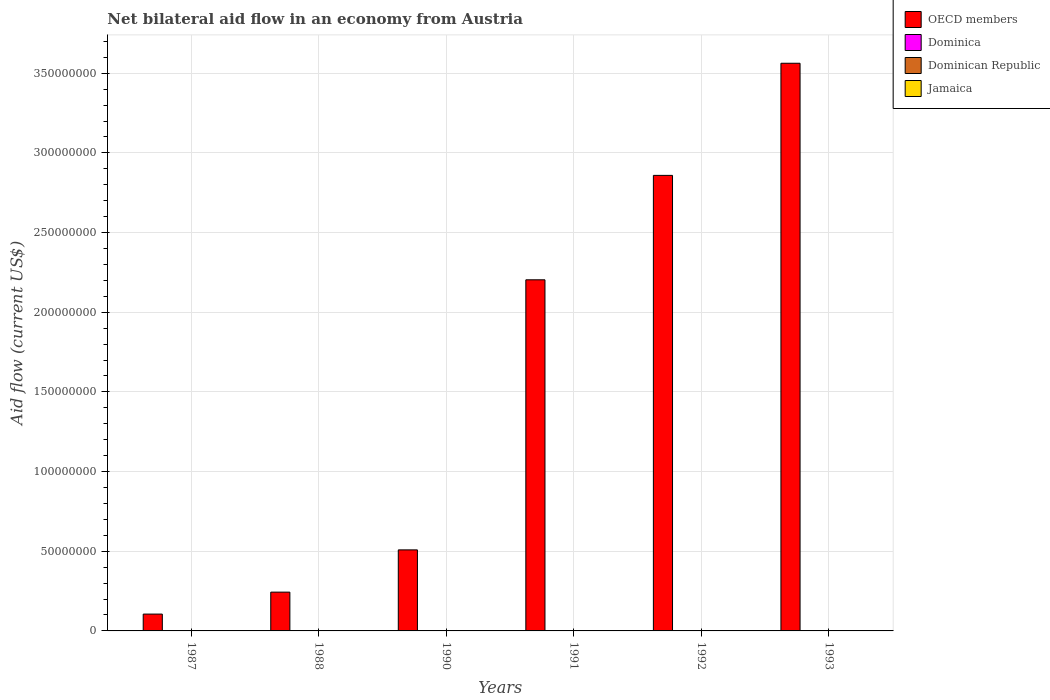How many different coloured bars are there?
Ensure brevity in your answer.  4. How many groups of bars are there?
Give a very brief answer. 6. Are the number of bars per tick equal to the number of legend labels?
Provide a succinct answer. Yes. How many bars are there on the 2nd tick from the left?
Keep it short and to the point. 4. How many bars are there on the 4th tick from the right?
Give a very brief answer. 4. In how many cases, is the number of bars for a given year not equal to the number of legend labels?
Your answer should be very brief. 0. What is the net bilateral aid flow in Dominica in 1990?
Keep it short and to the point. 10000. Across all years, what is the maximum net bilateral aid flow in Dominica?
Make the answer very short. 10000. Across all years, what is the minimum net bilateral aid flow in OECD members?
Give a very brief answer. 1.06e+07. In which year was the net bilateral aid flow in Jamaica maximum?
Give a very brief answer. 1990. In which year was the net bilateral aid flow in OECD members minimum?
Offer a terse response. 1987. What is the total net bilateral aid flow in Jamaica in the graph?
Make the answer very short. 1.20e+05. What is the difference between the net bilateral aid flow in OECD members in 1987 and that in 1988?
Your response must be concise. -1.38e+07. What is the average net bilateral aid flow in OECD members per year?
Offer a very short reply. 1.58e+08. In the year 1993, what is the difference between the net bilateral aid flow in OECD members and net bilateral aid flow in Dominican Republic?
Make the answer very short. 3.56e+08. What is the ratio of the net bilateral aid flow in OECD members in 1987 to that in 1988?
Your response must be concise. 0.43. Is the difference between the net bilateral aid flow in OECD members in 1988 and 1991 greater than the difference between the net bilateral aid flow in Dominican Republic in 1988 and 1991?
Your answer should be compact. No. What is the difference between the highest and the lowest net bilateral aid flow in Dominican Republic?
Ensure brevity in your answer.  3.00e+04. In how many years, is the net bilateral aid flow in Dominica greater than the average net bilateral aid flow in Dominica taken over all years?
Provide a succinct answer. 0. Is the sum of the net bilateral aid flow in Dominica in 1990 and 1991 greater than the maximum net bilateral aid flow in Jamaica across all years?
Keep it short and to the point. No. Is it the case that in every year, the sum of the net bilateral aid flow in Jamaica and net bilateral aid flow in OECD members is greater than the sum of net bilateral aid flow in Dominican Republic and net bilateral aid flow in Dominica?
Your answer should be very brief. Yes. What does the 1st bar from the left in 1990 represents?
Ensure brevity in your answer.  OECD members. What does the 1st bar from the right in 1993 represents?
Your answer should be compact. Jamaica. Is it the case that in every year, the sum of the net bilateral aid flow in Dominican Republic and net bilateral aid flow in OECD members is greater than the net bilateral aid flow in Dominica?
Your response must be concise. Yes. How many bars are there?
Make the answer very short. 24. Are all the bars in the graph horizontal?
Your answer should be compact. No. Does the graph contain any zero values?
Provide a short and direct response. No. Does the graph contain grids?
Your response must be concise. Yes. Where does the legend appear in the graph?
Make the answer very short. Top right. How are the legend labels stacked?
Give a very brief answer. Vertical. What is the title of the graph?
Give a very brief answer. Net bilateral aid flow in an economy from Austria. Does "Saudi Arabia" appear as one of the legend labels in the graph?
Your response must be concise. No. What is the label or title of the Y-axis?
Make the answer very short. Aid flow (current US$). What is the Aid flow (current US$) of OECD members in 1987?
Ensure brevity in your answer.  1.06e+07. What is the Aid flow (current US$) of Dominica in 1987?
Offer a terse response. 10000. What is the Aid flow (current US$) of Dominican Republic in 1987?
Make the answer very short. 2.00e+04. What is the Aid flow (current US$) in Jamaica in 1987?
Offer a terse response. 10000. What is the Aid flow (current US$) of OECD members in 1988?
Offer a terse response. 2.43e+07. What is the Aid flow (current US$) of Dominica in 1988?
Offer a terse response. 10000. What is the Aid flow (current US$) of Dominican Republic in 1988?
Your response must be concise. 10000. What is the Aid flow (current US$) in OECD members in 1990?
Make the answer very short. 5.09e+07. What is the Aid flow (current US$) of Dominican Republic in 1990?
Make the answer very short. 2.00e+04. What is the Aid flow (current US$) in OECD members in 1991?
Offer a terse response. 2.20e+08. What is the Aid flow (current US$) of Dominican Republic in 1991?
Your answer should be compact. 3.00e+04. What is the Aid flow (current US$) in OECD members in 1992?
Provide a short and direct response. 2.86e+08. What is the Aid flow (current US$) in Dominica in 1992?
Your answer should be very brief. 10000. What is the Aid flow (current US$) of Jamaica in 1992?
Offer a terse response. 3.00e+04. What is the Aid flow (current US$) of OECD members in 1993?
Keep it short and to the point. 3.56e+08. What is the Aid flow (current US$) of Dominica in 1993?
Give a very brief answer. 10000. What is the Aid flow (current US$) in Dominican Republic in 1993?
Provide a succinct answer. 4.00e+04. What is the Aid flow (current US$) of Jamaica in 1993?
Offer a terse response. 2.00e+04. Across all years, what is the maximum Aid flow (current US$) in OECD members?
Your answer should be very brief. 3.56e+08. Across all years, what is the maximum Aid flow (current US$) of Dominica?
Your response must be concise. 10000. Across all years, what is the minimum Aid flow (current US$) of OECD members?
Offer a terse response. 1.06e+07. Across all years, what is the minimum Aid flow (current US$) of Dominica?
Ensure brevity in your answer.  10000. Across all years, what is the minimum Aid flow (current US$) in Dominican Republic?
Make the answer very short. 10000. What is the total Aid flow (current US$) in OECD members in the graph?
Your response must be concise. 9.48e+08. What is the total Aid flow (current US$) of Dominica in the graph?
Offer a terse response. 6.00e+04. What is the total Aid flow (current US$) of Dominican Republic in the graph?
Provide a short and direct response. 1.60e+05. What is the total Aid flow (current US$) in Jamaica in the graph?
Ensure brevity in your answer.  1.20e+05. What is the difference between the Aid flow (current US$) in OECD members in 1987 and that in 1988?
Offer a terse response. -1.38e+07. What is the difference between the Aid flow (current US$) of Dominica in 1987 and that in 1988?
Make the answer very short. 0. What is the difference between the Aid flow (current US$) of Dominican Republic in 1987 and that in 1988?
Give a very brief answer. 10000. What is the difference between the Aid flow (current US$) of Jamaica in 1987 and that in 1988?
Your answer should be compact. 0. What is the difference between the Aid flow (current US$) of OECD members in 1987 and that in 1990?
Make the answer very short. -4.03e+07. What is the difference between the Aid flow (current US$) of OECD members in 1987 and that in 1991?
Give a very brief answer. -2.10e+08. What is the difference between the Aid flow (current US$) of Dominica in 1987 and that in 1991?
Your answer should be very brief. 0. What is the difference between the Aid flow (current US$) in Jamaica in 1987 and that in 1991?
Provide a short and direct response. 0. What is the difference between the Aid flow (current US$) of OECD members in 1987 and that in 1992?
Your answer should be very brief. -2.75e+08. What is the difference between the Aid flow (current US$) in Dominica in 1987 and that in 1992?
Your answer should be compact. 0. What is the difference between the Aid flow (current US$) in Dominican Republic in 1987 and that in 1992?
Your answer should be very brief. -2.00e+04. What is the difference between the Aid flow (current US$) in OECD members in 1987 and that in 1993?
Offer a very short reply. -3.46e+08. What is the difference between the Aid flow (current US$) of Dominica in 1987 and that in 1993?
Offer a very short reply. 0. What is the difference between the Aid flow (current US$) of OECD members in 1988 and that in 1990?
Provide a succinct answer. -2.65e+07. What is the difference between the Aid flow (current US$) in Dominican Republic in 1988 and that in 1990?
Your answer should be compact. -10000. What is the difference between the Aid flow (current US$) of OECD members in 1988 and that in 1991?
Offer a terse response. -1.96e+08. What is the difference between the Aid flow (current US$) in Dominican Republic in 1988 and that in 1991?
Provide a short and direct response. -2.00e+04. What is the difference between the Aid flow (current US$) in Jamaica in 1988 and that in 1991?
Ensure brevity in your answer.  0. What is the difference between the Aid flow (current US$) of OECD members in 1988 and that in 1992?
Keep it short and to the point. -2.62e+08. What is the difference between the Aid flow (current US$) in Dominica in 1988 and that in 1992?
Offer a very short reply. 0. What is the difference between the Aid flow (current US$) of Dominican Republic in 1988 and that in 1992?
Ensure brevity in your answer.  -3.00e+04. What is the difference between the Aid flow (current US$) in Jamaica in 1988 and that in 1992?
Ensure brevity in your answer.  -2.00e+04. What is the difference between the Aid flow (current US$) of OECD members in 1988 and that in 1993?
Provide a succinct answer. -3.32e+08. What is the difference between the Aid flow (current US$) of Jamaica in 1988 and that in 1993?
Make the answer very short. -10000. What is the difference between the Aid flow (current US$) in OECD members in 1990 and that in 1991?
Ensure brevity in your answer.  -1.70e+08. What is the difference between the Aid flow (current US$) of Dominica in 1990 and that in 1991?
Make the answer very short. 0. What is the difference between the Aid flow (current US$) of Dominican Republic in 1990 and that in 1991?
Keep it short and to the point. -10000. What is the difference between the Aid flow (current US$) of OECD members in 1990 and that in 1992?
Your answer should be compact. -2.35e+08. What is the difference between the Aid flow (current US$) of Dominica in 1990 and that in 1992?
Your response must be concise. 0. What is the difference between the Aid flow (current US$) of Jamaica in 1990 and that in 1992?
Offer a terse response. 10000. What is the difference between the Aid flow (current US$) in OECD members in 1990 and that in 1993?
Provide a short and direct response. -3.05e+08. What is the difference between the Aid flow (current US$) in Dominica in 1990 and that in 1993?
Provide a short and direct response. 0. What is the difference between the Aid flow (current US$) in Dominican Republic in 1990 and that in 1993?
Make the answer very short. -2.00e+04. What is the difference between the Aid flow (current US$) in Jamaica in 1990 and that in 1993?
Keep it short and to the point. 2.00e+04. What is the difference between the Aid flow (current US$) of OECD members in 1991 and that in 1992?
Keep it short and to the point. -6.55e+07. What is the difference between the Aid flow (current US$) in Dominica in 1991 and that in 1992?
Keep it short and to the point. 0. What is the difference between the Aid flow (current US$) of Dominican Republic in 1991 and that in 1992?
Your response must be concise. -10000. What is the difference between the Aid flow (current US$) of Jamaica in 1991 and that in 1992?
Keep it short and to the point. -2.00e+04. What is the difference between the Aid flow (current US$) of OECD members in 1991 and that in 1993?
Give a very brief answer. -1.36e+08. What is the difference between the Aid flow (current US$) of Dominican Republic in 1991 and that in 1993?
Your answer should be very brief. -10000. What is the difference between the Aid flow (current US$) in Jamaica in 1991 and that in 1993?
Your answer should be compact. -10000. What is the difference between the Aid flow (current US$) in OECD members in 1992 and that in 1993?
Your response must be concise. -7.04e+07. What is the difference between the Aid flow (current US$) of Dominican Republic in 1992 and that in 1993?
Your response must be concise. 0. What is the difference between the Aid flow (current US$) in OECD members in 1987 and the Aid flow (current US$) in Dominica in 1988?
Provide a short and direct response. 1.06e+07. What is the difference between the Aid flow (current US$) of OECD members in 1987 and the Aid flow (current US$) of Dominican Republic in 1988?
Provide a succinct answer. 1.06e+07. What is the difference between the Aid flow (current US$) in OECD members in 1987 and the Aid flow (current US$) in Jamaica in 1988?
Your answer should be very brief. 1.06e+07. What is the difference between the Aid flow (current US$) of Dominica in 1987 and the Aid flow (current US$) of Dominican Republic in 1988?
Provide a short and direct response. 0. What is the difference between the Aid flow (current US$) of Dominica in 1987 and the Aid flow (current US$) of Jamaica in 1988?
Provide a succinct answer. 0. What is the difference between the Aid flow (current US$) in OECD members in 1987 and the Aid flow (current US$) in Dominica in 1990?
Make the answer very short. 1.06e+07. What is the difference between the Aid flow (current US$) of OECD members in 1987 and the Aid flow (current US$) of Dominican Republic in 1990?
Provide a short and direct response. 1.06e+07. What is the difference between the Aid flow (current US$) of OECD members in 1987 and the Aid flow (current US$) of Jamaica in 1990?
Give a very brief answer. 1.05e+07. What is the difference between the Aid flow (current US$) in Dominica in 1987 and the Aid flow (current US$) in Dominican Republic in 1990?
Keep it short and to the point. -10000. What is the difference between the Aid flow (current US$) in OECD members in 1987 and the Aid flow (current US$) in Dominica in 1991?
Make the answer very short. 1.06e+07. What is the difference between the Aid flow (current US$) in OECD members in 1987 and the Aid flow (current US$) in Dominican Republic in 1991?
Give a very brief answer. 1.05e+07. What is the difference between the Aid flow (current US$) in OECD members in 1987 and the Aid flow (current US$) in Jamaica in 1991?
Make the answer very short. 1.06e+07. What is the difference between the Aid flow (current US$) of Dominica in 1987 and the Aid flow (current US$) of Dominican Republic in 1991?
Give a very brief answer. -2.00e+04. What is the difference between the Aid flow (current US$) in OECD members in 1987 and the Aid flow (current US$) in Dominica in 1992?
Keep it short and to the point. 1.06e+07. What is the difference between the Aid flow (current US$) in OECD members in 1987 and the Aid flow (current US$) in Dominican Republic in 1992?
Provide a short and direct response. 1.05e+07. What is the difference between the Aid flow (current US$) of OECD members in 1987 and the Aid flow (current US$) of Jamaica in 1992?
Ensure brevity in your answer.  1.05e+07. What is the difference between the Aid flow (current US$) in Dominica in 1987 and the Aid flow (current US$) in Jamaica in 1992?
Provide a short and direct response. -2.00e+04. What is the difference between the Aid flow (current US$) in Dominican Republic in 1987 and the Aid flow (current US$) in Jamaica in 1992?
Your answer should be compact. -10000. What is the difference between the Aid flow (current US$) in OECD members in 1987 and the Aid flow (current US$) in Dominica in 1993?
Keep it short and to the point. 1.06e+07. What is the difference between the Aid flow (current US$) in OECD members in 1987 and the Aid flow (current US$) in Dominican Republic in 1993?
Keep it short and to the point. 1.05e+07. What is the difference between the Aid flow (current US$) of OECD members in 1987 and the Aid flow (current US$) of Jamaica in 1993?
Give a very brief answer. 1.06e+07. What is the difference between the Aid flow (current US$) in Dominican Republic in 1987 and the Aid flow (current US$) in Jamaica in 1993?
Your response must be concise. 0. What is the difference between the Aid flow (current US$) in OECD members in 1988 and the Aid flow (current US$) in Dominica in 1990?
Provide a succinct answer. 2.43e+07. What is the difference between the Aid flow (current US$) of OECD members in 1988 and the Aid flow (current US$) of Dominican Republic in 1990?
Offer a terse response. 2.43e+07. What is the difference between the Aid flow (current US$) of OECD members in 1988 and the Aid flow (current US$) of Jamaica in 1990?
Keep it short and to the point. 2.43e+07. What is the difference between the Aid flow (current US$) of Dominica in 1988 and the Aid flow (current US$) of Dominican Republic in 1990?
Provide a succinct answer. -10000. What is the difference between the Aid flow (current US$) in Dominican Republic in 1988 and the Aid flow (current US$) in Jamaica in 1990?
Your response must be concise. -3.00e+04. What is the difference between the Aid flow (current US$) of OECD members in 1988 and the Aid flow (current US$) of Dominica in 1991?
Keep it short and to the point. 2.43e+07. What is the difference between the Aid flow (current US$) of OECD members in 1988 and the Aid flow (current US$) of Dominican Republic in 1991?
Give a very brief answer. 2.43e+07. What is the difference between the Aid flow (current US$) in OECD members in 1988 and the Aid flow (current US$) in Jamaica in 1991?
Offer a terse response. 2.43e+07. What is the difference between the Aid flow (current US$) in Dominica in 1988 and the Aid flow (current US$) in Dominican Republic in 1991?
Your answer should be compact. -2.00e+04. What is the difference between the Aid flow (current US$) in Dominica in 1988 and the Aid flow (current US$) in Jamaica in 1991?
Offer a very short reply. 0. What is the difference between the Aid flow (current US$) of Dominican Republic in 1988 and the Aid flow (current US$) of Jamaica in 1991?
Provide a short and direct response. 0. What is the difference between the Aid flow (current US$) in OECD members in 1988 and the Aid flow (current US$) in Dominica in 1992?
Offer a terse response. 2.43e+07. What is the difference between the Aid flow (current US$) in OECD members in 1988 and the Aid flow (current US$) in Dominican Republic in 1992?
Make the answer very short. 2.43e+07. What is the difference between the Aid flow (current US$) of OECD members in 1988 and the Aid flow (current US$) of Jamaica in 1992?
Your response must be concise. 2.43e+07. What is the difference between the Aid flow (current US$) of Dominica in 1988 and the Aid flow (current US$) of Dominican Republic in 1992?
Give a very brief answer. -3.00e+04. What is the difference between the Aid flow (current US$) of Dominica in 1988 and the Aid flow (current US$) of Jamaica in 1992?
Give a very brief answer. -2.00e+04. What is the difference between the Aid flow (current US$) in OECD members in 1988 and the Aid flow (current US$) in Dominica in 1993?
Offer a very short reply. 2.43e+07. What is the difference between the Aid flow (current US$) of OECD members in 1988 and the Aid flow (current US$) of Dominican Republic in 1993?
Give a very brief answer. 2.43e+07. What is the difference between the Aid flow (current US$) in OECD members in 1988 and the Aid flow (current US$) in Jamaica in 1993?
Ensure brevity in your answer.  2.43e+07. What is the difference between the Aid flow (current US$) of Dominican Republic in 1988 and the Aid flow (current US$) of Jamaica in 1993?
Offer a terse response. -10000. What is the difference between the Aid flow (current US$) in OECD members in 1990 and the Aid flow (current US$) in Dominica in 1991?
Provide a short and direct response. 5.08e+07. What is the difference between the Aid flow (current US$) in OECD members in 1990 and the Aid flow (current US$) in Dominican Republic in 1991?
Your response must be concise. 5.08e+07. What is the difference between the Aid flow (current US$) of OECD members in 1990 and the Aid flow (current US$) of Jamaica in 1991?
Keep it short and to the point. 5.08e+07. What is the difference between the Aid flow (current US$) in OECD members in 1990 and the Aid flow (current US$) in Dominica in 1992?
Provide a succinct answer. 5.08e+07. What is the difference between the Aid flow (current US$) in OECD members in 1990 and the Aid flow (current US$) in Dominican Republic in 1992?
Provide a short and direct response. 5.08e+07. What is the difference between the Aid flow (current US$) in OECD members in 1990 and the Aid flow (current US$) in Jamaica in 1992?
Provide a succinct answer. 5.08e+07. What is the difference between the Aid flow (current US$) in Dominica in 1990 and the Aid flow (current US$) in Jamaica in 1992?
Make the answer very short. -2.00e+04. What is the difference between the Aid flow (current US$) of OECD members in 1990 and the Aid flow (current US$) of Dominica in 1993?
Your answer should be compact. 5.08e+07. What is the difference between the Aid flow (current US$) of OECD members in 1990 and the Aid flow (current US$) of Dominican Republic in 1993?
Your answer should be very brief. 5.08e+07. What is the difference between the Aid flow (current US$) of OECD members in 1990 and the Aid flow (current US$) of Jamaica in 1993?
Your answer should be very brief. 5.08e+07. What is the difference between the Aid flow (current US$) of Dominican Republic in 1990 and the Aid flow (current US$) of Jamaica in 1993?
Keep it short and to the point. 0. What is the difference between the Aid flow (current US$) in OECD members in 1991 and the Aid flow (current US$) in Dominica in 1992?
Your answer should be compact. 2.20e+08. What is the difference between the Aid flow (current US$) of OECD members in 1991 and the Aid flow (current US$) of Dominican Republic in 1992?
Offer a very short reply. 2.20e+08. What is the difference between the Aid flow (current US$) in OECD members in 1991 and the Aid flow (current US$) in Jamaica in 1992?
Give a very brief answer. 2.20e+08. What is the difference between the Aid flow (current US$) of OECD members in 1991 and the Aid flow (current US$) of Dominica in 1993?
Give a very brief answer. 2.20e+08. What is the difference between the Aid flow (current US$) in OECD members in 1991 and the Aid flow (current US$) in Dominican Republic in 1993?
Your answer should be very brief. 2.20e+08. What is the difference between the Aid flow (current US$) in OECD members in 1991 and the Aid flow (current US$) in Jamaica in 1993?
Keep it short and to the point. 2.20e+08. What is the difference between the Aid flow (current US$) of Dominica in 1991 and the Aid flow (current US$) of Dominican Republic in 1993?
Your answer should be very brief. -3.00e+04. What is the difference between the Aid flow (current US$) in Dominica in 1991 and the Aid flow (current US$) in Jamaica in 1993?
Keep it short and to the point. -10000. What is the difference between the Aid flow (current US$) in Dominican Republic in 1991 and the Aid flow (current US$) in Jamaica in 1993?
Offer a terse response. 10000. What is the difference between the Aid flow (current US$) of OECD members in 1992 and the Aid flow (current US$) of Dominica in 1993?
Your answer should be compact. 2.86e+08. What is the difference between the Aid flow (current US$) of OECD members in 1992 and the Aid flow (current US$) of Dominican Republic in 1993?
Make the answer very short. 2.86e+08. What is the difference between the Aid flow (current US$) of OECD members in 1992 and the Aid flow (current US$) of Jamaica in 1993?
Give a very brief answer. 2.86e+08. What is the difference between the Aid flow (current US$) of Dominica in 1992 and the Aid flow (current US$) of Dominican Republic in 1993?
Offer a very short reply. -3.00e+04. What is the difference between the Aid flow (current US$) of Dominica in 1992 and the Aid flow (current US$) of Jamaica in 1993?
Your answer should be very brief. -10000. What is the difference between the Aid flow (current US$) in Dominican Republic in 1992 and the Aid flow (current US$) in Jamaica in 1993?
Your answer should be compact. 2.00e+04. What is the average Aid flow (current US$) of OECD members per year?
Ensure brevity in your answer.  1.58e+08. What is the average Aid flow (current US$) of Dominica per year?
Make the answer very short. 10000. What is the average Aid flow (current US$) in Dominican Republic per year?
Ensure brevity in your answer.  2.67e+04. What is the average Aid flow (current US$) of Jamaica per year?
Your response must be concise. 2.00e+04. In the year 1987, what is the difference between the Aid flow (current US$) in OECD members and Aid flow (current US$) in Dominica?
Make the answer very short. 1.06e+07. In the year 1987, what is the difference between the Aid flow (current US$) in OECD members and Aid flow (current US$) in Dominican Republic?
Provide a succinct answer. 1.06e+07. In the year 1987, what is the difference between the Aid flow (current US$) in OECD members and Aid flow (current US$) in Jamaica?
Provide a succinct answer. 1.06e+07. In the year 1988, what is the difference between the Aid flow (current US$) of OECD members and Aid flow (current US$) of Dominica?
Your answer should be compact. 2.43e+07. In the year 1988, what is the difference between the Aid flow (current US$) of OECD members and Aid flow (current US$) of Dominican Republic?
Give a very brief answer. 2.43e+07. In the year 1988, what is the difference between the Aid flow (current US$) of OECD members and Aid flow (current US$) of Jamaica?
Ensure brevity in your answer.  2.43e+07. In the year 1988, what is the difference between the Aid flow (current US$) in Dominica and Aid flow (current US$) in Dominican Republic?
Make the answer very short. 0. In the year 1988, what is the difference between the Aid flow (current US$) of Dominica and Aid flow (current US$) of Jamaica?
Your response must be concise. 0. In the year 1988, what is the difference between the Aid flow (current US$) in Dominican Republic and Aid flow (current US$) in Jamaica?
Offer a terse response. 0. In the year 1990, what is the difference between the Aid flow (current US$) of OECD members and Aid flow (current US$) of Dominica?
Offer a very short reply. 5.08e+07. In the year 1990, what is the difference between the Aid flow (current US$) of OECD members and Aid flow (current US$) of Dominican Republic?
Make the answer very short. 5.08e+07. In the year 1990, what is the difference between the Aid flow (current US$) in OECD members and Aid flow (current US$) in Jamaica?
Provide a succinct answer. 5.08e+07. In the year 1990, what is the difference between the Aid flow (current US$) of Dominica and Aid flow (current US$) of Dominican Republic?
Your answer should be very brief. -10000. In the year 1990, what is the difference between the Aid flow (current US$) in Dominica and Aid flow (current US$) in Jamaica?
Offer a terse response. -3.00e+04. In the year 1990, what is the difference between the Aid flow (current US$) of Dominican Republic and Aid flow (current US$) of Jamaica?
Make the answer very short. -2.00e+04. In the year 1991, what is the difference between the Aid flow (current US$) in OECD members and Aid flow (current US$) in Dominica?
Make the answer very short. 2.20e+08. In the year 1991, what is the difference between the Aid flow (current US$) in OECD members and Aid flow (current US$) in Dominican Republic?
Your response must be concise. 2.20e+08. In the year 1991, what is the difference between the Aid flow (current US$) of OECD members and Aid flow (current US$) of Jamaica?
Offer a very short reply. 2.20e+08. In the year 1992, what is the difference between the Aid flow (current US$) in OECD members and Aid flow (current US$) in Dominica?
Your response must be concise. 2.86e+08. In the year 1992, what is the difference between the Aid flow (current US$) of OECD members and Aid flow (current US$) of Dominican Republic?
Ensure brevity in your answer.  2.86e+08. In the year 1992, what is the difference between the Aid flow (current US$) of OECD members and Aid flow (current US$) of Jamaica?
Your response must be concise. 2.86e+08. In the year 1992, what is the difference between the Aid flow (current US$) in Dominica and Aid flow (current US$) in Dominican Republic?
Ensure brevity in your answer.  -3.00e+04. In the year 1992, what is the difference between the Aid flow (current US$) in Dominica and Aid flow (current US$) in Jamaica?
Your answer should be compact. -2.00e+04. In the year 1992, what is the difference between the Aid flow (current US$) in Dominican Republic and Aid flow (current US$) in Jamaica?
Make the answer very short. 10000. In the year 1993, what is the difference between the Aid flow (current US$) in OECD members and Aid flow (current US$) in Dominica?
Your answer should be very brief. 3.56e+08. In the year 1993, what is the difference between the Aid flow (current US$) in OECD members and Aid flow (current US$) in Dominican Republic?
Give a very brief answer. 3.56e+08. In the year 1993, what is the difference between the Aid flow (current US$) of OECD members and Aid flow (current US$) of Jamaica?
Make the answer very short. 3.56e+08. In the year 1993, what is the difference between the Aid flow (current US$) in Dominican Republic and Aid flow (current US$) in Jamaica?
Provide a succinct answer. 2.00e+04. What is the ratio of the Aid flow (current US$) of OECD members in 1987 to that in 1988?
Offer a terse response. 0.43. What is the ratio of the Aid flow (current US$) in Dominica in 1987 to that in 1988?
Provide a short and direct response. 1. What is the ratio of the Aid flow (current US$) of Jamaica in 1987 to that in 1988?
Give a very brief answer. 1. What is the ratio of the Aid flow (current US$) of OECD members in 1987 to that in 1990?
Provide a short and direct response. 0.21. What is the ratio of the Aid flow (current US$) in Dominica in 1987 to that in 1990?
Your response must be concise. 1. What is the ratio of the Aid flow (current US$) in Dominican Republic in 1987 to that in 1990?
Your answer should be very brief. 1. What is the ratio of the Aid flow (current US$) in OECD members in 1987 to that in 1991?
Keep it short and to the point. 0.05. What is the ratio of the Aid flow (current US$) in Dominican Republic in 1987 to that in 1991?
Provide a succinct answer. 0.67. What is the ratio of the Aid flow (current US$) of Jamaica in 1987 to that in 1991?
Keep it short and to the point. 1. What is the ratio of the Aid flow (current US$) in OECD members in 1987 to that in 1992?
Offer a terse response. 0.04. What is the ratio of the Aid flow (current US$) in Dominican Republic in 1987 to that in 1992?
Offer a very short reply. 0.5. What is the ratio of the Aid flow (current US$) in Jamaica in 1987 to that in 1992?
Keep it short and to the point. 0.33. What is the ratio of the Aid flow (current US$) in OECD members in 1987 to that in 1993?
Provide a short and direct response. 0.03. What is the ratio of the Aid flow (current US$) of Dominica in 1987 to that in 1993?
Make the answer very short. 1. What is the ratio of the Aid flow (current US$) of Dominican Republic in 1987 to that in 1993?
Offer a terse response. 0.5. What is the ratio of the Aid flow (current US$) of OECD members in 1988 to that in 1990?
Make the answer very short. 0.48. What is the ratio of the Aid flow (current US$) of Dominican Republic in 1988 to that in 1990?
Give a very brief answer. 0.5. What is the ratio of the Aid flow (current US$) in OECD members in 1988 to that in 1991?
Give a very brief answer. 0.11. What is the ratio of the Aid flow (current US$) of Jamaica in 1988 to that in 1991?
Make the answer very short. 1. What is the ratio of the Aid flow (current US$) in OECD members in 1988 to that in 1992?
Your answer should be very brief. 0.09. What is the ratio of the Aid flow (current US$) in Dominican Republic in 1988 to that in 1992?
Your answer should be very brief. 0.25. What is the ratio of the Aid flow (current US$) in OECD members in 1988 to that in 1993?
Your answer should be compact. 0.07. What is the ratio of the Aid flow (current US$) in Dominica in 1988 to that in 1993?
Give a very brief answer. 1. What is the ratio of the Aid flow (current US$) of Jamaica in 1988 to that in 1993?
Your answer should be compact. 0.5. What is the ratio of the Aid flow (current US$) of OECD members in 1990 to that in 1991?
Your answer should be compact. 0.23. What is the ratio of the Aid flow (current US$) in Dominica in 1990 to that in 1991?
Your response must be concise. 1. What is the ratio of the Aid flow (current US$) in Dominican Republic in 1990 to that in 1991?
Offer a very short reply. 0.67. What is the ratio of the Aid flow (current US$) in OECD members in 1990 to that in 1992?
Offer a terse response. 0.18. What is the ratio of the Aid flow (current US$) in Dominica in 1990 to that in 1992?
Make the answer very short. 1. What is the ratio of the Aid flow (current US$) in Dominican Republic in 1990 to that in 1992?
Provide a succinct answer. 0.5. What is the ratio of the Aid flow (current US$) in OECD members in 1990 to that in 1993?
Offer a terse response. 0.14. What is the ratio of the Aid flow (current US$) of Dominica in 1990 to that in 1993?
Ensure brevity in your answer.  1. What is the ratio of the Aid flow (current US$) of Jamaica in 1990 to that in 1993?
Provide a short and direct response. 2. What is the ratio of the Aid flow (current US$) in OECD members in 1991 to that in 1992?
Offer a very short reply. 0.77. What is the ratio of the Aid flow (current US$) in Dominica in 1991 to that in 1992?
Keep it short and to the point. 1. What is the ratio of the Aid flow (current US$) in Dominican Republic in 1991 to that in 1992?
Offer a terse response. 0.75. What is the ratio of the Aid flow (current US$) in OECD members in 1991 to that in 1993?
Offer a very short reply. 0.62. What is the ratio of the Aid flow (current US$) in Dominica in 1991 to that in 1993?
Your answer should be very brief. 1. What is the ratio of the Aid flow (current US$) of Jamaica in 1991 to that in 1993?
Keep it short and to the point. 0.5. What is the ratio of the Aid flow (current US$) of OECD members in 1992 to that in 1993?
Give a very brief answer. 0.8. What is the ratio of the Aid flow (current US$) of Jamaica in 1992 to that in 1993?
Provide a short and direct response. 1.5. What is the difference between the highest and the second highest Aid flow (current US$) in OECD members?
Ensure brevity in your answer.  7.04e+07. What is the difference between the highest and the second highest Aid flow (current US$) in Dominica?
Your answer should be compact. 0. What is the difference between the highest and the second highest Aid flow (current US$) in Dominican Republic?
Provide a short and direct response. 0. What is the difference between the highest and the lowest Aid flow (current US$) in OECD members?
Give a very brief answer. 3.46e+08. What is the difference between the highest and the lowest Aid flow (current US$) of Dominica?
Your answer should be compact. 0. What is the difference between the highest and the lowest Aid flow (current US$) in Dominican Republic?
Provide a short and direct response. 3.00e+04. 